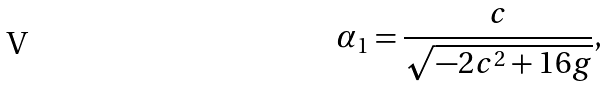Convert formula to latex. <formula><loc_0><loc_0><loc_500><loc_500>\alpha _ { 1 } = \frac { c } { \sqrt { - 2 c ^ { 2 } + 1 6 g } } ,</formula> 